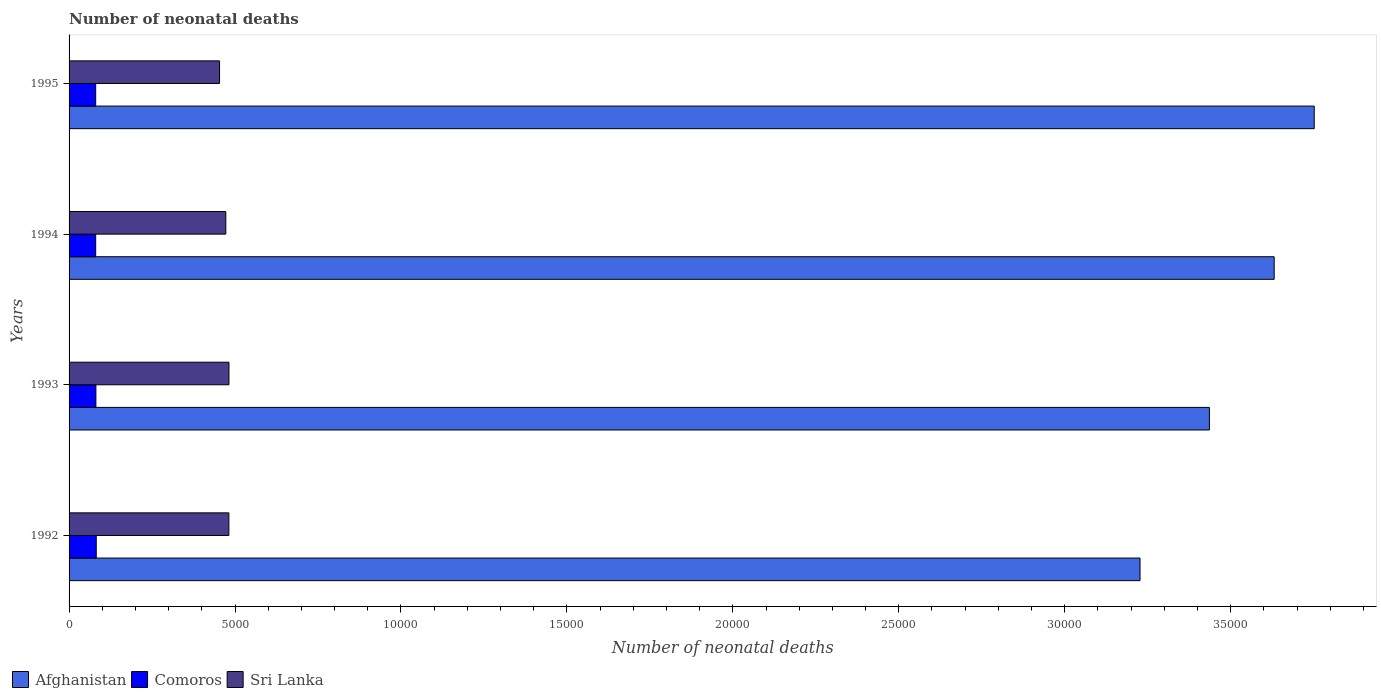How many groups of bars are there?
Provide a short and direct response. 4. Are the number of bars per tick equal to the number of legend labels?
Provide a short and direct response. Yes. How many bars are there on the 3rd tick from the top?
Make the answer very short. 3. How many bars are there on the 2nd tick from the bottom?
Give a very brief answer. 3. What is the label of the 2nd group of bars from the top?
Your answer should be very brief. 1994. What is the number of neonatal deaths in in Afghanistan in 1995?
Keep it short and to the point. 3.75e+04. Across all years, what is the maximum number of neonatal deaths in in Sri Lanka?
Offer a very short reply. 4818. Across all years, what is the minimum number of neonatal deaths in in Afghanistan?
Provide a short and direct response. 3.23e+04. What is the total number of neonatal deaths in in Afghanistan in the graph?
Make the answer very short. 1.40e+05. What is the difference between the number of neonatal deaths in in Comoros in 1992 and that in 1993?
Provide a succinct answer. 11. What is the difference between the number of neonatal deaths in in Afghanistan in 1993 and the number of neonatal deaths in in Comoros in 1994?
Provide a short and direct response. 3.36e+04. What is the average number of neonatal deaths in in Comoros per year?
Provide a succinct answer. 807.75. In the year 1993, what is the difference between the number of neonatal deaths in in Sri Lanka and number of neonatal deaths in in Afghanistan?
Give a very brief answer. -2.95e+04. In how many years, is the number of neonatal deaths in in Afghanistan greater than 3000 ?
Keep it short and to the point. 4. What is the ratio of the number of neonatal deaths in in Comoros in 1994 to that in 1995?
Provide a succinct answer. 1. Is the number of neonatal deaths in in Afghanistan in 1992 less than that in 1995?
Ensure brevity in your answer.  Yes. What is the difference between the highest and the second highest number of neonatal deaths in in Afghanistan?
Offer a very short reply. 1207. What is the difference between the highest and the lowest number of neonatal deaths in in Sri Lanka?
Your answer should be very brief. 284. In how many years, is the number of neonatal deaths in in Afghanistan greater than the average number of neonatal deaths in in Afghanistan taken over all years?
Provide a succinct answer. 2. Is the sum of the number of neonatal deaths in in Sri Lanka in 1992 and 1995 greater than the maximum number of neonatal deaths in in Afghanistan across all years?
Give a very brief answer. No. What does the 3rd bar from the top in 1993 represents?
Provide a succinct answer. Afghanistan. What does the 1st bar from the bottom in 1995 represents?
Give a very brief answer. Afghanistan. How many bars are there?
Give a very brief answer. 12. Are the values on the major ticks of X-axis written in scientific E-notation?
Offer a very short reply. No. Where does the legend appear in the graph?
Offer a terse response. Bottom left. How many legend labels are there?
Provide a succinct answer. 3. How are the legend labels stacked?
Your answer should be very brief. Horizontal. What is the title of the graph?
Make the answer very short. Number of neonatal deaths. Does "Virgin Islands" appear as one of the legend labels in the graph?
Offer a very short reply. No. What is the label or title of the X-axis?
Make the answer very short. Number of neonatal deaths. What is the Number of neonatal deaths in Afghanistan in 1992?
Keep it short and to the point. 3.23e+04. What is the Number of neonatal deaths in Comoros in 1992?
Offer a terse response. 819. What is the Number of neonatal deaths of Sri Lanka in 1992?
Ensure brevity in your answer.  4815. What is the Number of neonatal deaths of Afghanistan in 1993?
Offer a terse response. 3.44e+04. What is the Number of neonatal deaths of Comoros in 1993?
Provide a short and direct response. 808. What is the Number of neonatal deaths in Sri Lanka in 1993?
Offer a very short reply. 4818. What is the Number of neonatal deaths in Afghanistan in 1994?
Provide a short and direct response. 3.63e+04. What is the Number of neonatal deaths in Comoros in 1994?
Offer a terse response. 802. What is the Number of neonatal deaths in Sri Lanka in 1994?
Give a very brief answer. 4723. What is the Number of neonatal deaths in Afghanistan in 1995?
Ensure brevity in your answer.  3.75e+04. What is the Number of neonatal deaths in Comoros in 1995?
Provide a succinct answer. 802. What is the Number of neonatal deaths of Sri Lanka in 1995?
Keep it short and to the point. 4534. Across all years, what is the maximum Number of neonatal deaths in Afghanistan?
Keep it short and to the point. 3.75e+04. Across all years, what is the maximum Number of neonatal deaths of Comoros?
Provide a short and direct response. 819. Across all years, what is the maximum Number of neonatal deaths in Sri Lanka?
Your response must be concise. 4818. Across all years, what is the minimum Number of neonatal deaths in Afghanistan?
Provide a short and direct response. 3.23e+04. Across all years, what is the minimum Number of neonatal deaths of Comoros?
Your response must be concise. 802. Across all years, what is the minimum Number of neonatal deaths in Sri Lanka?
Your answer should be very brief. 4534. What is the total Number of neonatal deaths in Afghanistan in the graph?
Ensure brevity in your answer.  1.40e+05. What is the total Number of neonatal deaths of Comoros in the graph?
Make the answer very short. 3231. What is the total Number of neonatal deaths of Sri Lanka in the graph?
Ensure brevity in your answer.  1.89e+04. What is the difference between the Number of neonatal deaths of Afghanistan in 1992 and that in 1993?
Make the answer very short. -2091. What is the difference between the Number of neonatal deaths in Comoros in 1992 and that in 1993?
Provide a succinct answer. 11. What is the difference between the Number of neonatal deaths in Afghanistan in 1992 and that in 1994?
Provide a succinct answer. -4042. What is the difference between the Number of neonatal deaths in Comoros in 1992 and that in 1994?
Offer a very short reply. 17. What is the difference between the Number of neonatal deaths of Sri Lanka in 1992 and that in 1994?
Provide a succinct answer. 92. What is the difference between the Number of neonatal deaths in Afghanistan in 1992 and that in 1995?
Provide a short and direct response. -5249. What is the difference between the Number of neonatal deaths in Sri Lanka in 1992 and that in 1995?
Ensure brevity in your answer.  281. What is the difference between the Number of neonatal deaths in Afghanistan in 1993 and that in 1994?
Offer a terse response. -1951. What is the difference between the Number of neonatal deaths of Afghanistan in 1993 and that in 1995?
Offer a very short reply. -3158. What is the difference between the Number of neonatal deaths of Sri Lanka in 1993 and that in 1995?
Ensure brevity in your answer.  284. What is the difference between the Number of neonatal deaths in Afghanistan in 1994 and that in 1995?
Ensure brevity in your answer.  -1207. What is the difference between the Number of neonatal deaths of Comoros in 1994 and that in 1995?
Ensure brevity in your answer.  0. What is the difference between the Number of neonatal deaths of Sri Lanka in 1994 and that in 1995?
Keep it short and to the point. 189. What is the difference between the Number of neonatal deaths in Afghanistan in 1992 and the Number of neonatal deaths in Comoros in 1993?
Ensure brevity in your answer.  3.15e+04. What is the difference between the Number of neonatal deaths in Afghanistan in 1992 and the Number of neonatal deaths in Sri Lanka in 1993?
Make the answer very short. 2.75e+04. What is the difference between the Number of neonatal deaths in Comoros in 1992 and the Number of neonatal deaths in Sri Lanka in 1993?
Ensure brevity in your answer.  -3999. What is the difference between the Number of neonatal deaths in Afghanistan in 1992 and the Number of neonatal deaths in Comoros in 1994?
Offer a very short reply. 3.15e+04. What is the difference between the Number of neonatal deaths in Afghanistan in 1992 and the Number of neonatal deaths in Sri Lanka in 1994?
Ensure brevity in your answer.  2.75e+04. What is the difference between the Number of neonatal deaths in Comoros in 1992 and the Number of neonatal deaths in Sri Lanka in 1994?
Your answer should be compact. -3904. What is the difference between the Number of neonatal deaths of Afghanistan in 1992 and the Number of neonatal deaths of Comoros in 1995?
Make the answer very short. 3.15e+04. What is the difference between the Number of neonatal deaths of Afghanistan in 1992 and the Number of neonatal deaths of Sri Lanka in 1995?
Give a very brief answer. 2.77e+04. What is the difference between the Number of neonatal deaths in Comoros in 1992 and the Number of neonatal deaths in Sri Lanka in 1995?
Make the answer very short. -3715. What is the difference between the Number of neonatal deaths in Afghanistan in 1993 and the Number of neonatal deaths in Comoros in 1994?
Make the answer very short. 3.36e+04. What is the difference between the Number of neonatal deaths in Afghanistan in 1993 and the Number of neonatal deaths in Sri Lanka in 1994?
Make the answer very short. 2.96e+04. What is the difference between the Number of neonatal deaths in Comoros in 1993 and the Number of neonatal deaths in Sri Lanka in 1994?
Your answer should be very brief. -3915. What is the difference between the Number of neonatal deaths of Afghanistan in 1993 and the Number of neonatal deaths of Comoros in 1995?
Your response must be concise. 3.36e+04. What is the difference between the Number of neonatal deaths in Afghanistan in 1993 and the Number of neonatal deaths in Sri Lanka in 1995?
Your response must be concise. 2.98e+04. What is the difference between the Number of neonatal deaths of Comoros in 1993 and the Number of neonatal deaths of Sri Lanka in 1995?
Offer a terse response. -3726. What is the difference between the Number of neonatal deaths in Afghanistan in 1994 and the Number of neonatal deaths in Comoros in 1995?
Offer a very short reply. 3.55e+04. What is the difference between the Number of neonatal deaths in Afghanistan in 1994 and the Number of neonatal deaths in Sri Lanka in 1995?
Provide a succinct answer. 3.18e+04. What is the difference between the Number of neonatal deaths of Comoros in 1994 and the Number of neonatal deaths of Sri Lanka in 1995?
Provide a short and direct response. -3732. What is the average Number of neonatal deaths in Afghanistan per year?
Give a very brief answer. 3.51e+04. What is the average Number of neonatal deaths in Comoros per year?
Offer a very short reply. 807.75. What is the average Number of neonatal deaths in Sri Lanka per year?
Offer a very short reply. 4722.5. In the year 1992, what is the difference between the Number of neonatal deaths of Afghanistan and Number of neonatal deaths of Comoros?
Your answer should be very brief. 3.15e+04. In the year 1992, what is the difference between the Number of neonatal deaths of Afghanistan and Number of neonatal deaths of Sri Lanka?
Ensure brevity in your answer.  2.75e+04. In the year 1992, what is the difference between the Number of neonatal deaths of Comoros and Number of neonatal deaths of Sri Lanka?
Provide a succinct answer. -3996. In the year 1993, what is the difference between the Number of neonatal deaths of Afghanistan and Number of neonatal deaths of Comoros?
Your response must be concise. 3.36e+04. In the year 1993, what is the difference between the Number of neonatal deaths in Afghanistan and Number of neonatal deaths in Sri Lanka?
Give a very brief answer. 2.95e+04. In the year 1993, what is the difference between the Number of neonatal deaths in Comoros and Number of neonatal deaths in Sri Lanka?
Make the answer very short. -4010. In the year 1994, what is the difference between the Number of neonatal deaths of Afghanistan and Number of neonatal deaths of Comoros?
Make the answer very short. 3.55e+04. In the year 1994, what is the difference between the Number of neonatal deaths of Afghanistan and Number of neonatal deaths of Sri Lanka?
Provide a succinct answer. 3.16e+04. In the year 1994, what is the difference between the Number of neonatal deaths in Comoros and Number of neonatal deaths in Sri Lanka?
Provide a short and direct response. -3921. In the year 1995, what is the difference between the Number of neonatal deaths in Afghanistan and Number of neonatal deaths in Comoros?
Offer a terse response. 3.67e+04. In the year 1995, what is the difference between the Number of neonatal deaths of Afghanistan and Number of neonatal deaths of Sri Lanka?
Your response must be concise. 3.30e+04. In the year 1995, what is the difference between the Number of neonatal deaths in Comoros and Number of neonatal deaths in Sri Lanka?
Your response must be concise. -3732. What is the ratio of the Number of neonatal deaths in Afghanistan in 1992 to that in 1993?
Offer a terse response. 0.94. What is the ratio of the Number of neonatal deaths of Comoros in 1992 to that in 1993?
Offer a terse response. 1.01. What is the ratio of the Number of neonatal deaths in Sri Lanka in 1992 to that in 1993?
Make the answer very short. 1. What is the ratio of the Number of neonatal deaths in Afghanistan in 1992 to that in 1994?
Your answer should be very brief. 0.89. What is the ratio of the Number of neonatal deaths in Comoros in 1992 to that in 1994?
Provide a succinct answer. 1.02. What is the ratio of the Number of neonatal deaths of Sri Lanka in 1992 to that in 1994?
Offer a terse response. 1.02. What is the ratio of the Number of neonatal deaths of Afghanistan in 1992 to that in 1995?
Your answer should be compact. 0.86. What is the ratio of the Number of neonatal deaths in Comoros in 1992 to that in 1995?
Your response must be concise. 1.02. What is the ratio of the Number of neonatal deaths of Sri Lanka in 1992 to that in 1995?
Keep it short and to the point. 1.06. What is the ratio of the Number of neonatal deaths of Afghanistan in 1993 to that in 1994?
Make the answer very short. 0.95. What is the ratio of the Number of neonatal deaths in Comoros in 1993 to that in 1994?
Your answer should be very brief. 1.01. What is the ratio of the Number of neonatal deaths of Sri Lanka in 1993 to that in 1994?
Provide a short and direct response. 1.02. What is the ratio of the Number of neonatal deaths of Afghanistan in 1993 to that in 1995?
Ensure brevity in your answer.  0.92. What is the ratio of the Number of neonatal deaths in Comoros in 1993 to that in 1995?
Provide a succinct answer. 1.01. What is the ratio of the Number of neonatal deaths of Sri Lanka in 1993 to that in 1995?
Give a very brief answer. 1.06. What is the ratio of the Number of neonatal deaths in Afghanistan in 1994 to that in 1995?
Ensure brevity in your answer.  0.97. What is the ratio of the Number of neonatal deaths of Sri Lanka in 1994 to that in 1995?
Offer a terse response. 1.04. What is the difference between the highest and the second highest Number of neonatal deaths of Afghanistan?
Give a very brief answer. 1207. What is the difference between the highest and the second highest Number of neonatal deaths of Comoros?
Offer a terse response. 11. What is the difference between the highest and the lowest Number of neonatal deaths in Afghanistan?
Make the answer very short. 5249. What is the difference between the highest and the lowest Number of neonatal deaths in Sri Lanka?
Provide a short and direct response. 284. 